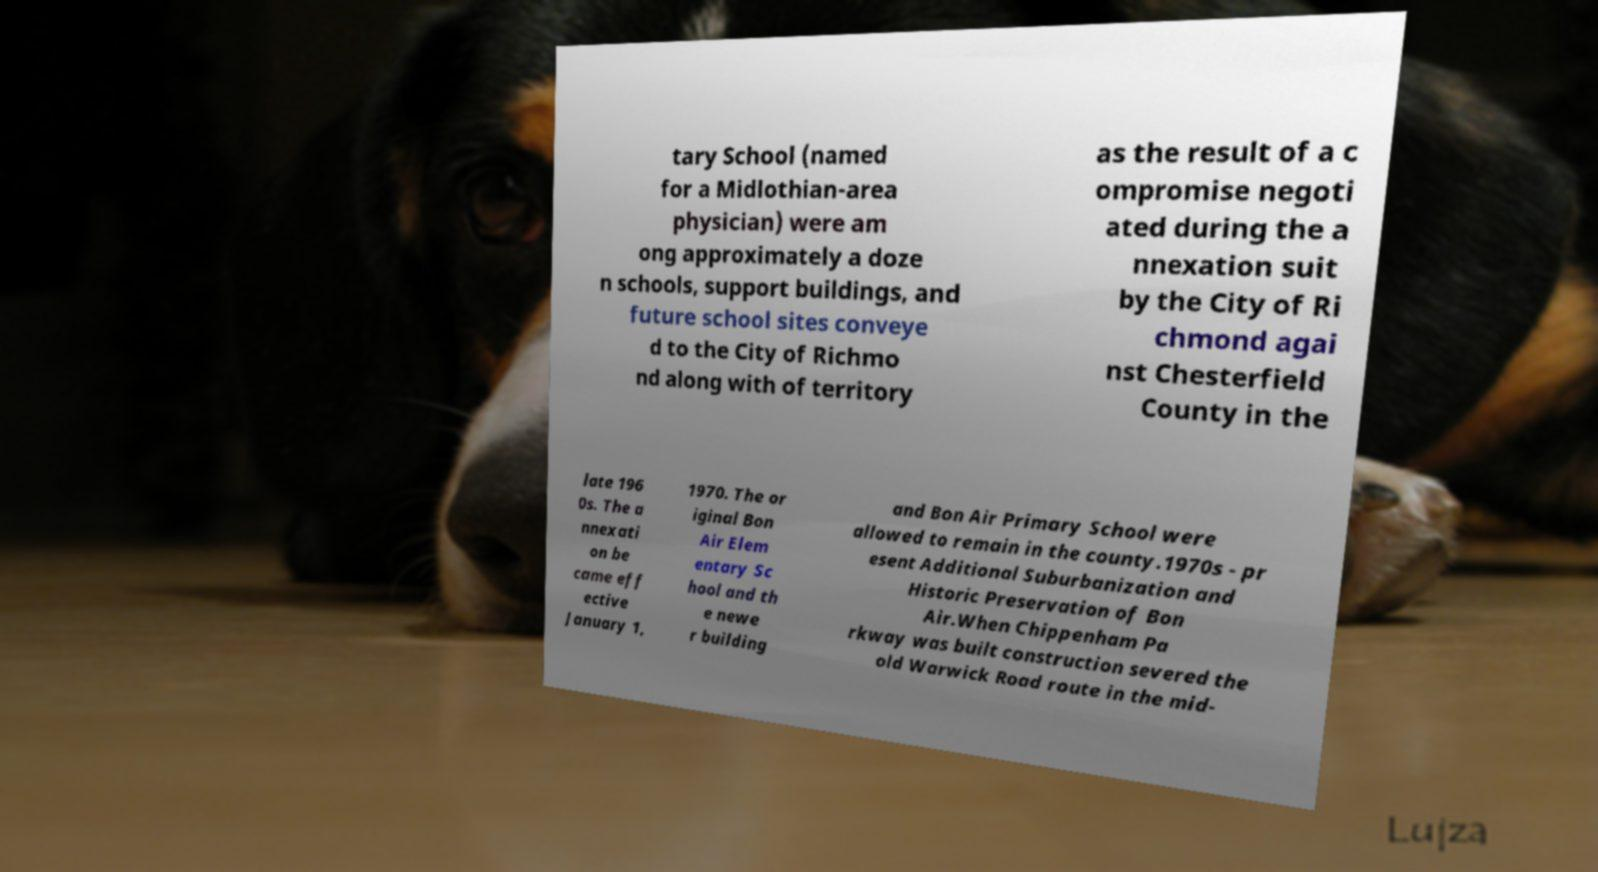There's text embedded in this image that I need extracted. Can you transcribe it verbatim? tary School (named for a Midlothian-area physician) were am ong approximately a doze n schools, support buildings, and future school sites conveye d to the City of Richmo nd along with of territory as the result of a c ompromise negoti ated during the a nnexation suit by the City of Ri chmond agai nst Chesterfield County in the late 196 0s. The a nnexati on be came eff ective January 1, 1970. The or iginal Bon Air Elem entary Sc hool and th e newe r building and Bon Air Primary School were allowed to remain in the county.1970s - pr esent Additional Suburbanization and Historic Preservation of Bon Air.When Chippenham Pa rkway was built construction severed the old Warwick Road route in the mid- 